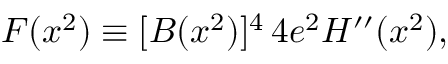<formula> <loc_0><loc_0><loc_500><loc_500>F ( x ^ { 2 } ) \equiv [ B ( x ^ { 2 } ) ] ^ { 4 } \, 4 e ^ { 2 } H ^ { \prime \prime } ( x ^ { 2 } ) ,</formula> 